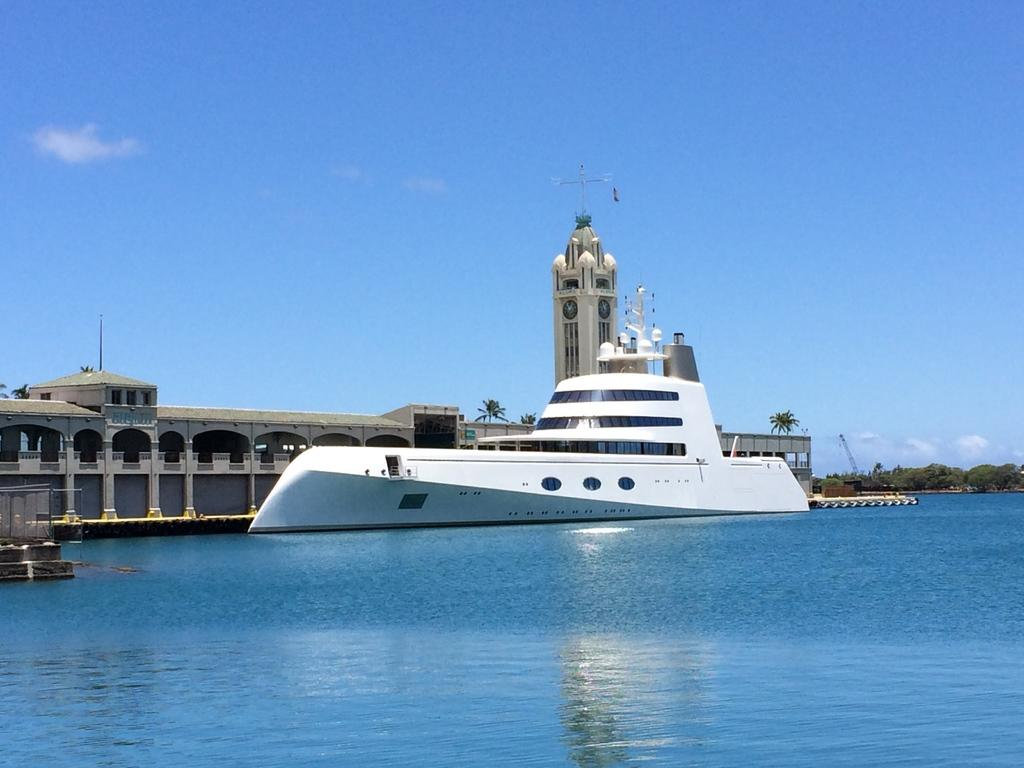What is the primary element in the image? There is water in the image. What is floating on the water? There is a white-colored ship on the water. What can be seen in the background of the image? There are trees and clouds in the background of the image. What part of the natural environment is visible in the image? The sky is visible in the background of the image. Where is the hammer located in the image? There is no hammer present in the image. Can you see any hands holding the ship in the image? There are no hands visible in the image, and the ship is not being held by any hands. --- 